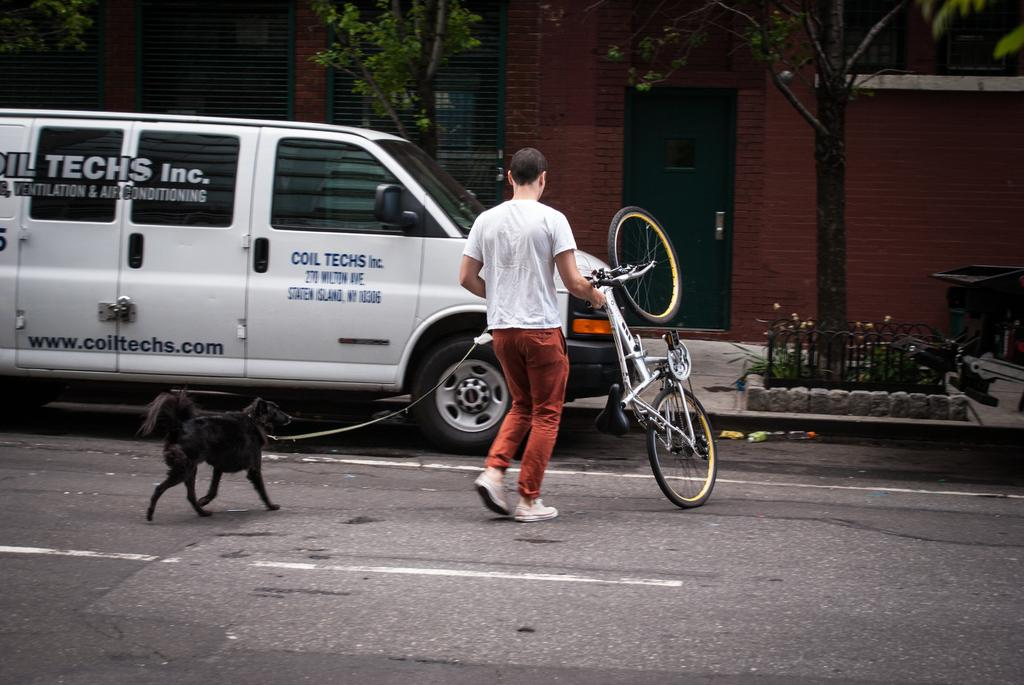Who or what can be seen in the image? There is a person and a dog in the image. What are the person and dog doing in the image? The person and dog are walking on the road. What else is present in the image? There is a vehicle parked beside the road, trees, plants, and a trash bin in front of a building. What type of animals can be seen in the zoo in the image? There is no zoo present in the image; it features a person and a dog walking on the road. Can you tell me where the church is located in the image? There is no church present in the image. 